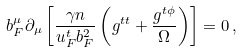<formula> <loc_0><loc_0><loc_500><loc_500>b _ { F } ^ { \mu } \partial _ { \mu } \left [ \frac { \gamma n } { u _ { F } ^ { t } b _ { F } ^ { 2 } } \left ( g ^ { t t } + \frac { g ^ { t \phi } } { \Omega } \right ) \right ] = 0 \, ,</formula> 